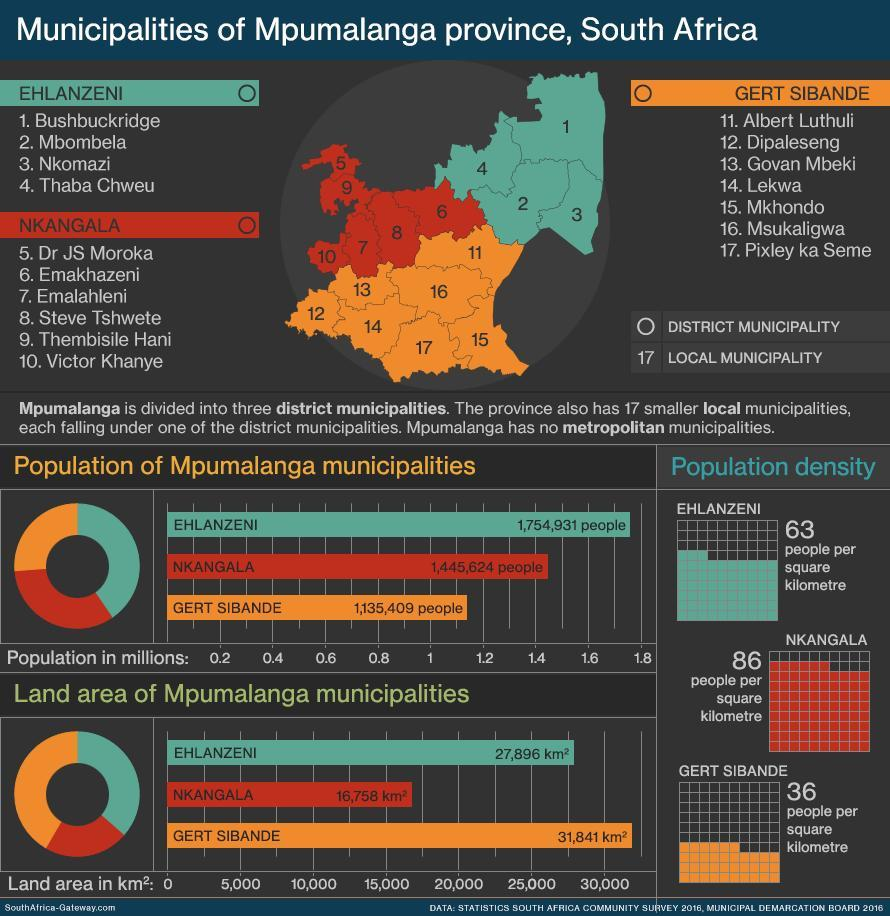Which color used to represent Gert Sibande-red, blue, orange, white?
Answer the question with a short phrase. orange Which color used to represent Nkangala-orange, blue, red, white? red 